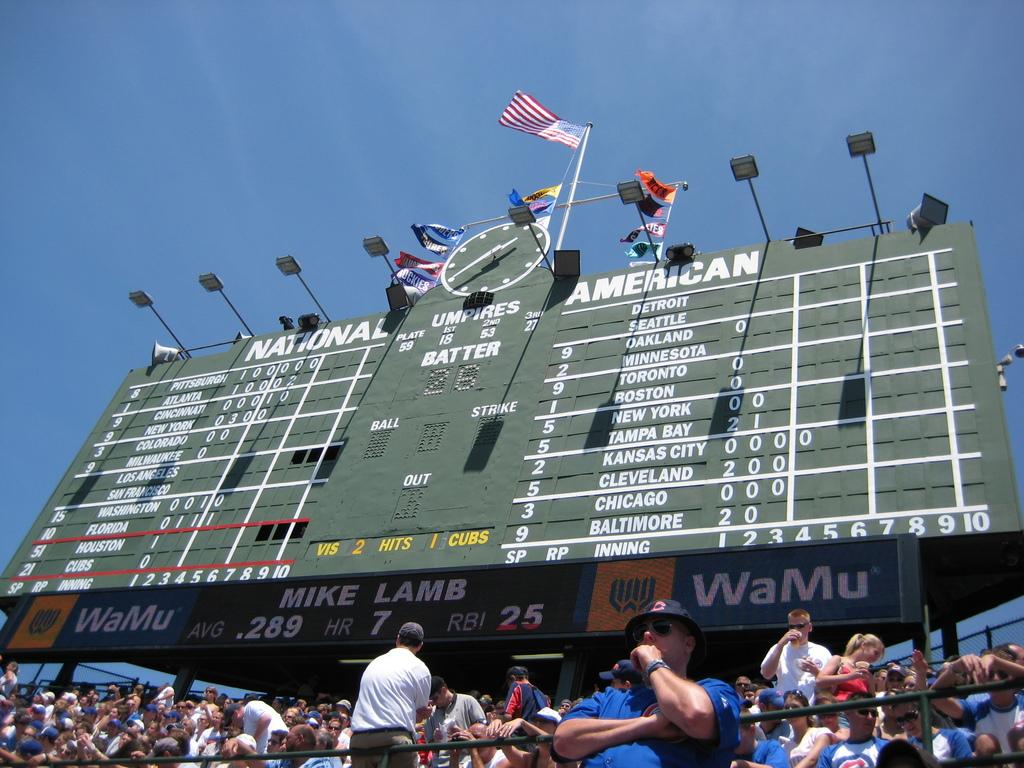<image>
Give a short and clear explanation of the subsequent image. The WaMu sponsored scoreboard shows the statistics for player Mike Lamb. 